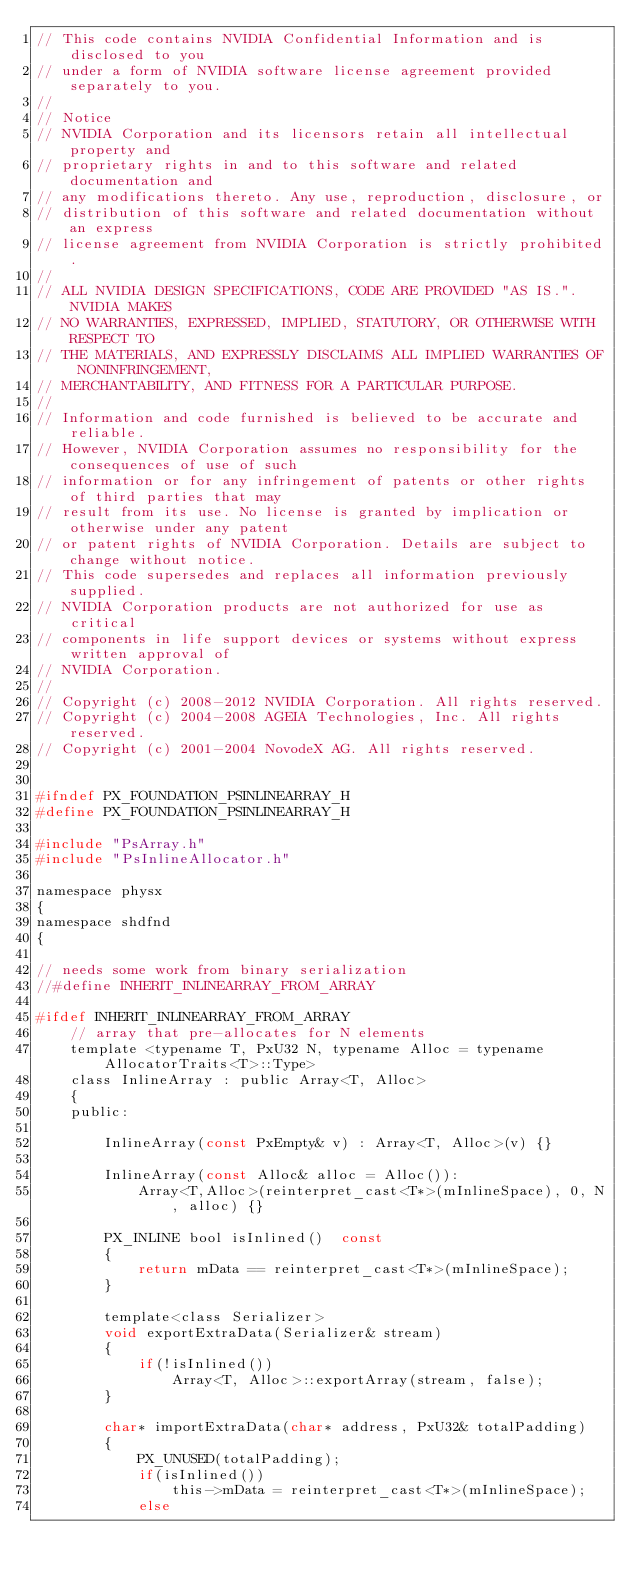<code> <loc_0><loc_0><loc_500><loc_500><_C_>// This code contains NVIDIA Confidential Information and is disclosed to you 
// under a form of NVIDIA software license agreement provided separately to you.
//
// Notice
// NVIDIA Corporation and its licensors retain all intellectual property and
// proprietary rights in and to this software and related documentation and 
// any modifications thereto. Any use, reproduction, disclosure, or 
// distribution of this software and related documentation without an express 
// license agreement from NVIDIA Corporation is strictly prohibited.
// 
// ALL NVIDIA DESIGN SPECIFICATIONS, CODE ARE PROVIDED "AS IS.". NVIDIA MAKES
// NO WARRANTIES, EXPRESSED, IMPLIED, STATUTORY, OR OTHERWISE WITH RESPECT TO
// THE MATERIALS, AND EXPRESSLY DISCLAIMS ALL IMPLIED WARRANTIES OF NONINFRINGEMENT,
// MERCHANTABILITY, AND FITNESS FOR A PARTICULAR PURPOSE.
//
// Information and code furnished is believed to be accurate and reliable.
// However, NVIDIA Corporation assumes no responsibility for the consequences of use of such
// information or for any infringement of patents or other rights of third parties that may
// result from its use. No license is granted by implication or otherwise under any patent
// or patent rights of NVIDIA Corporation. Details are subject to change without notice.
// This code supersedes and replaces all information previously supplied.
// NVIDIA Corporation products are not authorized for use as critical
// components in life support devices or systems without express written approval of
// NVIDIA Corporation.
//
// Copyright (c) 2008-2012 NVIDIA Corporation. All rights reserved.
// Copyright (c) 2004-2008 AGEIA Technologies, Inc. All rights reserved.
// Copyright (c) 2001-2004 NovodeX AG. All rights reserved.  


#ifndef PX_FOUNDATION_PSINLINEARRAY_H
#define PX_FOUNDATION_PSINLINEARRAY_H

#include "PsArray.h"
#include "PsInlineAllocator.h"

namespace physx
{
namespace shdfnd
{

// needs some work from binary serialization
//#define INHERIT_INLINEARRAY_FROM_ARRAY 

#ifdef INHERIT_INLINEARRAY_FROM_ARRAY
	// array that pre-allocates for N elements
	template <typename T, PxU32 N, typename Alloc = typename AllocatorTraits<T>::Type>
	class InlineArray : public Array<T, Alloc> 
	{
	public:

		InlineArray(const PxEmpty& v) : Array<T, Alloc>(v) {}

		InlineArray(const Alloc& alloc = Alloc()): 
			Array<T,Alloc>(reinterpret_cast<T*>(mInlineSpace), 0, N, alloc) {}

		PX_INLINE bool isInlined()	const
		{
			return mData == reinterpret_cast<T*>(mInlineSpace);
		}

		template<class Serializer>
		void exportExtraData(Serializer& stream)
		{
			if(!isInlined())
				Array<T, Alloc>::exportArray(stream, false);
		}

		char* importExtraData(char* address, PxU32& totalPadding)
		{
			PX_UNUSED(totalPadding);
			if(isInlined())
				this->mData = reinterpret_cast<T*>(mInlineSpace);
			else</code> 